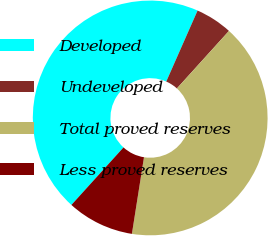Convert chart. <chart><loc_0><loc_0><loc_500><loc_500><pie_chart><fcel>Developed<fcel>Undeveloped<fcel>Total proved reserves<fcel>Less proved reserves<nl><fcel>44.9%<fcel>5.1%<fcel>40.78%<fcel>9.22%<nl></chart> 